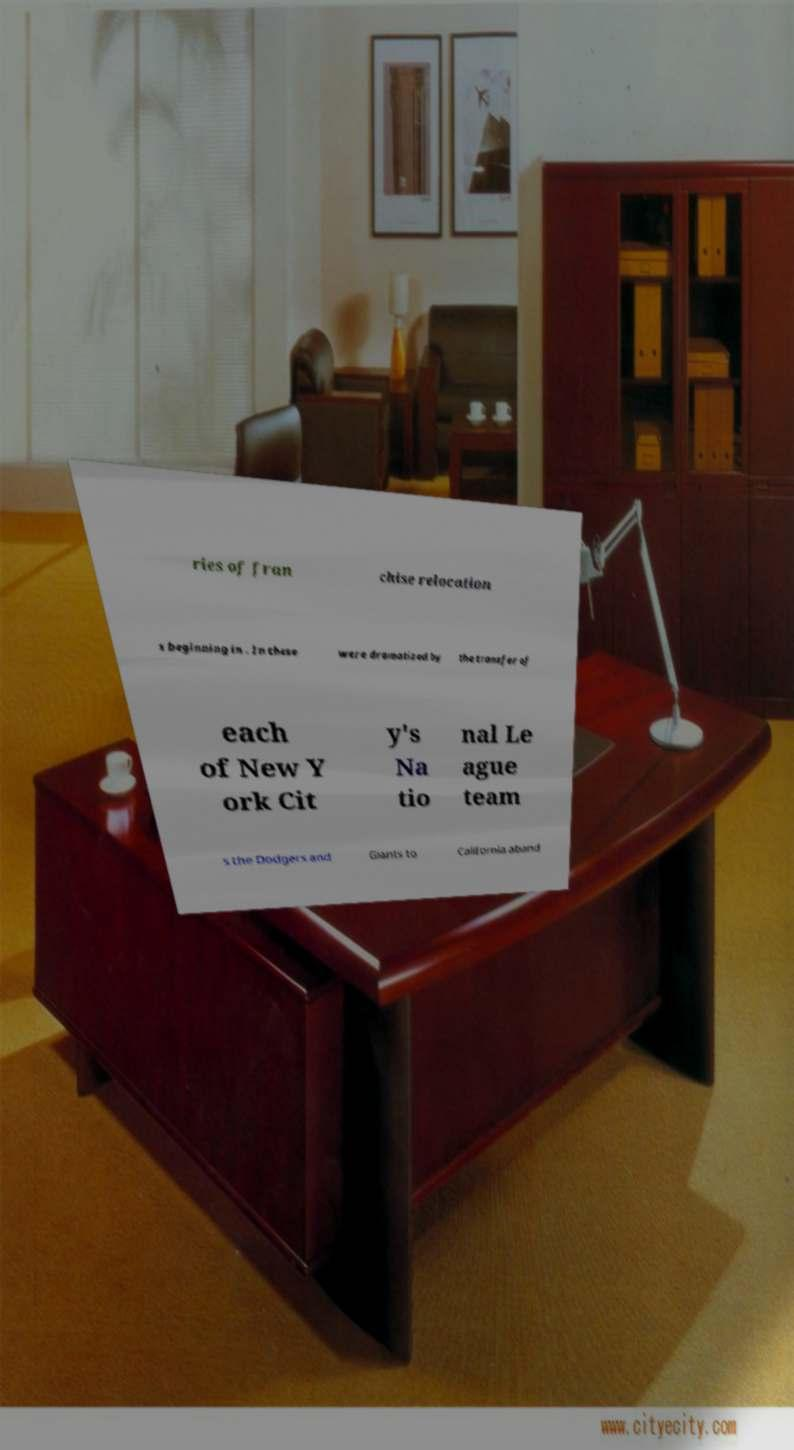I need the written content from this picture converted into text. Can you do that? ries of fran chise relocation s beginning in . In these were dramatized by the transfer of each of New Y ork Cit y's Na tio nal Le ague team s the Dodgers and Giants to California aband 